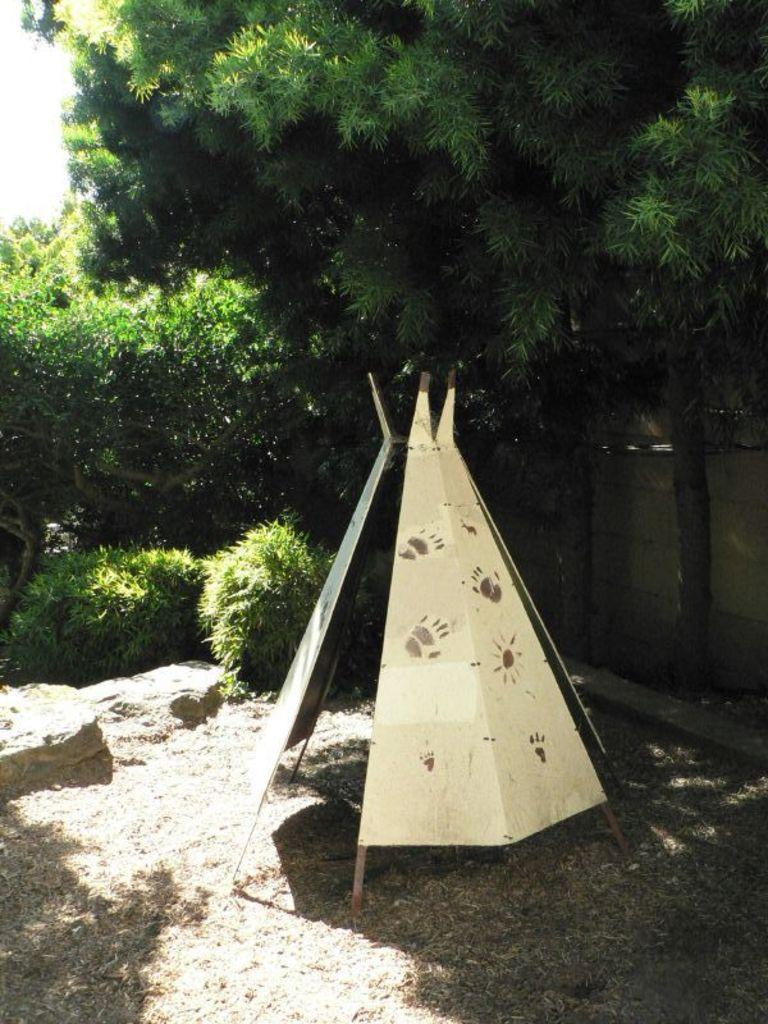What type of structure is present in the image? There is a tipi in the image. What can be seen in the background of the image? There are trees and plants in the background of the image. What part of the natural environment is visible in the image? The sky is visible in the background of the image. Where are the tomatoes and cherries located in the image? There are no tomatoes or cherries present in the image. 